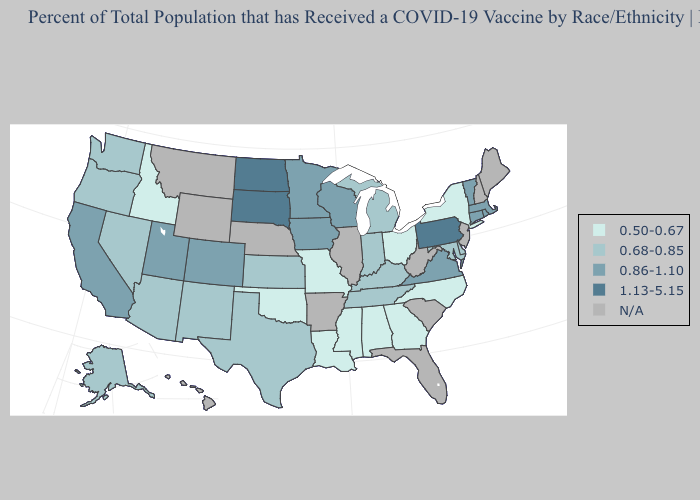Which states have the highest value in the USA?
Quick response, please. North Dakota, Pennsylvania, South Dakota. Does the map have missing data?
Keep it brief. Yes. Name the states that have a value in the range 0.50-0.67?
Concise answer only. Alabama, Georgia, Idaho, Louisiana, Mississippi, Missouri, New York, North Carolina, Ohio, Oklahoma. Name the states that have a value in the range 1.13-5.15?
Short answer required. North Dakota, Pennsylvania, South Dakota. What is the lowest value in the West?
Quick response, please. 0.50-0.67. What is the value of Wyoming?
Write a very short answer. N/A. Among the states that border Iowa , which have the highest value?
Keep it brief. South Dakota. What is the lowest value in states that border Illinois?
Give a very brief answer. 0.50-0.67. Name the states that have a value in the range 0.68-0.85?
Quick response, please. Alaska, Arizona, Delaware, Indiana, Kansas, Kentucky, Maryland, Michigan, Nevada, New Mexico, Oregon, Tennessee, Texas, Washington. Name the states that have a value in the range 0.86-1.10?
Write a very short answer. California, Colorado, Connecticut, Iowa, Massachusetts, Minnesota, Rhode Island, Utah, Vermont, Virginia, Wisconsin. How many symbols are there in the legend?
Keep it brief. 5. What is the value of Vermont?
Be succinct. 0.86-1.10. Name the states that have a value in the range 1.13-5.15?
Write a very short answer. North Dakota, Pennsylvania, South Dakota. What is the lowest value in the USA?
Answer briefly. 0.50-0.67. 